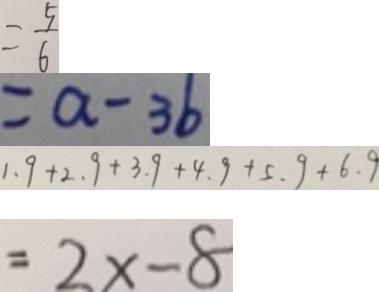<formula> <loc_0><loc_0><loc_500><loc_500>= \frac { 5 } { 6 } 
 = a - 3 b 
 1 . 9 + 2 . 9 + 3 . 9 + 4 . 9 + 5 . 9 + 6 . 9 
 = 2 x - 8</formula> 